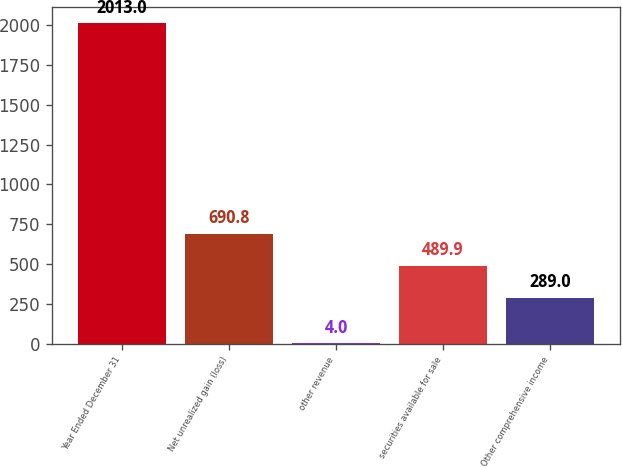Convert chart. <chart><loc_0><loc_0><loc_500><loc_500><bar_chart><fcel>Year Ended December 31<fcel>Net unrealized gain (loss)<fcel>other revenue<fcel>securities available for sale<fcel>Other comprehensive income<nl><fcel>2013<fcel>690.8<fcel>4<fcel>489.9<fcel>289<nl></chart> 